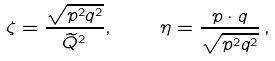Convert formula to latex. <formula><loc_0><loc_0><loc_500><loc_500>\zeta = \frac { \sqrt { p ^ { 2 } q ^ { 2 } } } { \widetilde { Q } ^ { 2 } } , \quad \eta = \frac { p \cdot q } { \sqrt { p ^ { 2 } q ^ { 2 } } } \, ,</formula> 